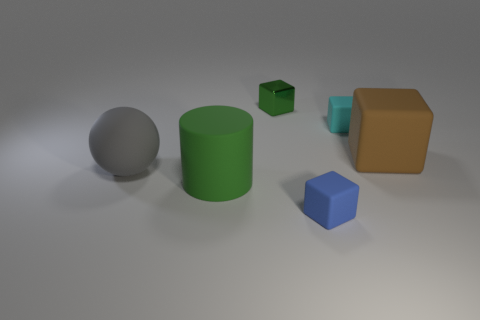How many other things are there of the same material as the tiny cyan object?
Your response must be concise. 4. There is a small blue matte object; what number of small green metal things are right of it?
Your answer should be compact. 0. What number of cylinders are either blue objects or small cyan rubber things?
Give a very brief answer. 0. There is a block that is in front of the tiny cyan thing and left of the big brown rubber object; what size is it?
Your response must be concise. Small. What number of other things are the same color as the large rubber cylinder?
Your response must be concise. 1. Does the cylinder have the same material as the tiny block that is in front of the big gray ball?
Give a very brief answer. Yes. What number of things are either matte things right of the tiny metallic object or small cyan rubber cylinders?
Your answer should be very brief. 3. What is the shape of the matte thing that is in front of the large brown matte object and on the right side of the large green matte cylinder?
Your response must be concise. Cube. Is there any other thing that is the same size as the metal thing?
Provide a short and direct response. Yes. There is a green object that is made of the same material as the large ball; what size is it?
Offer a very short reply. Large. 